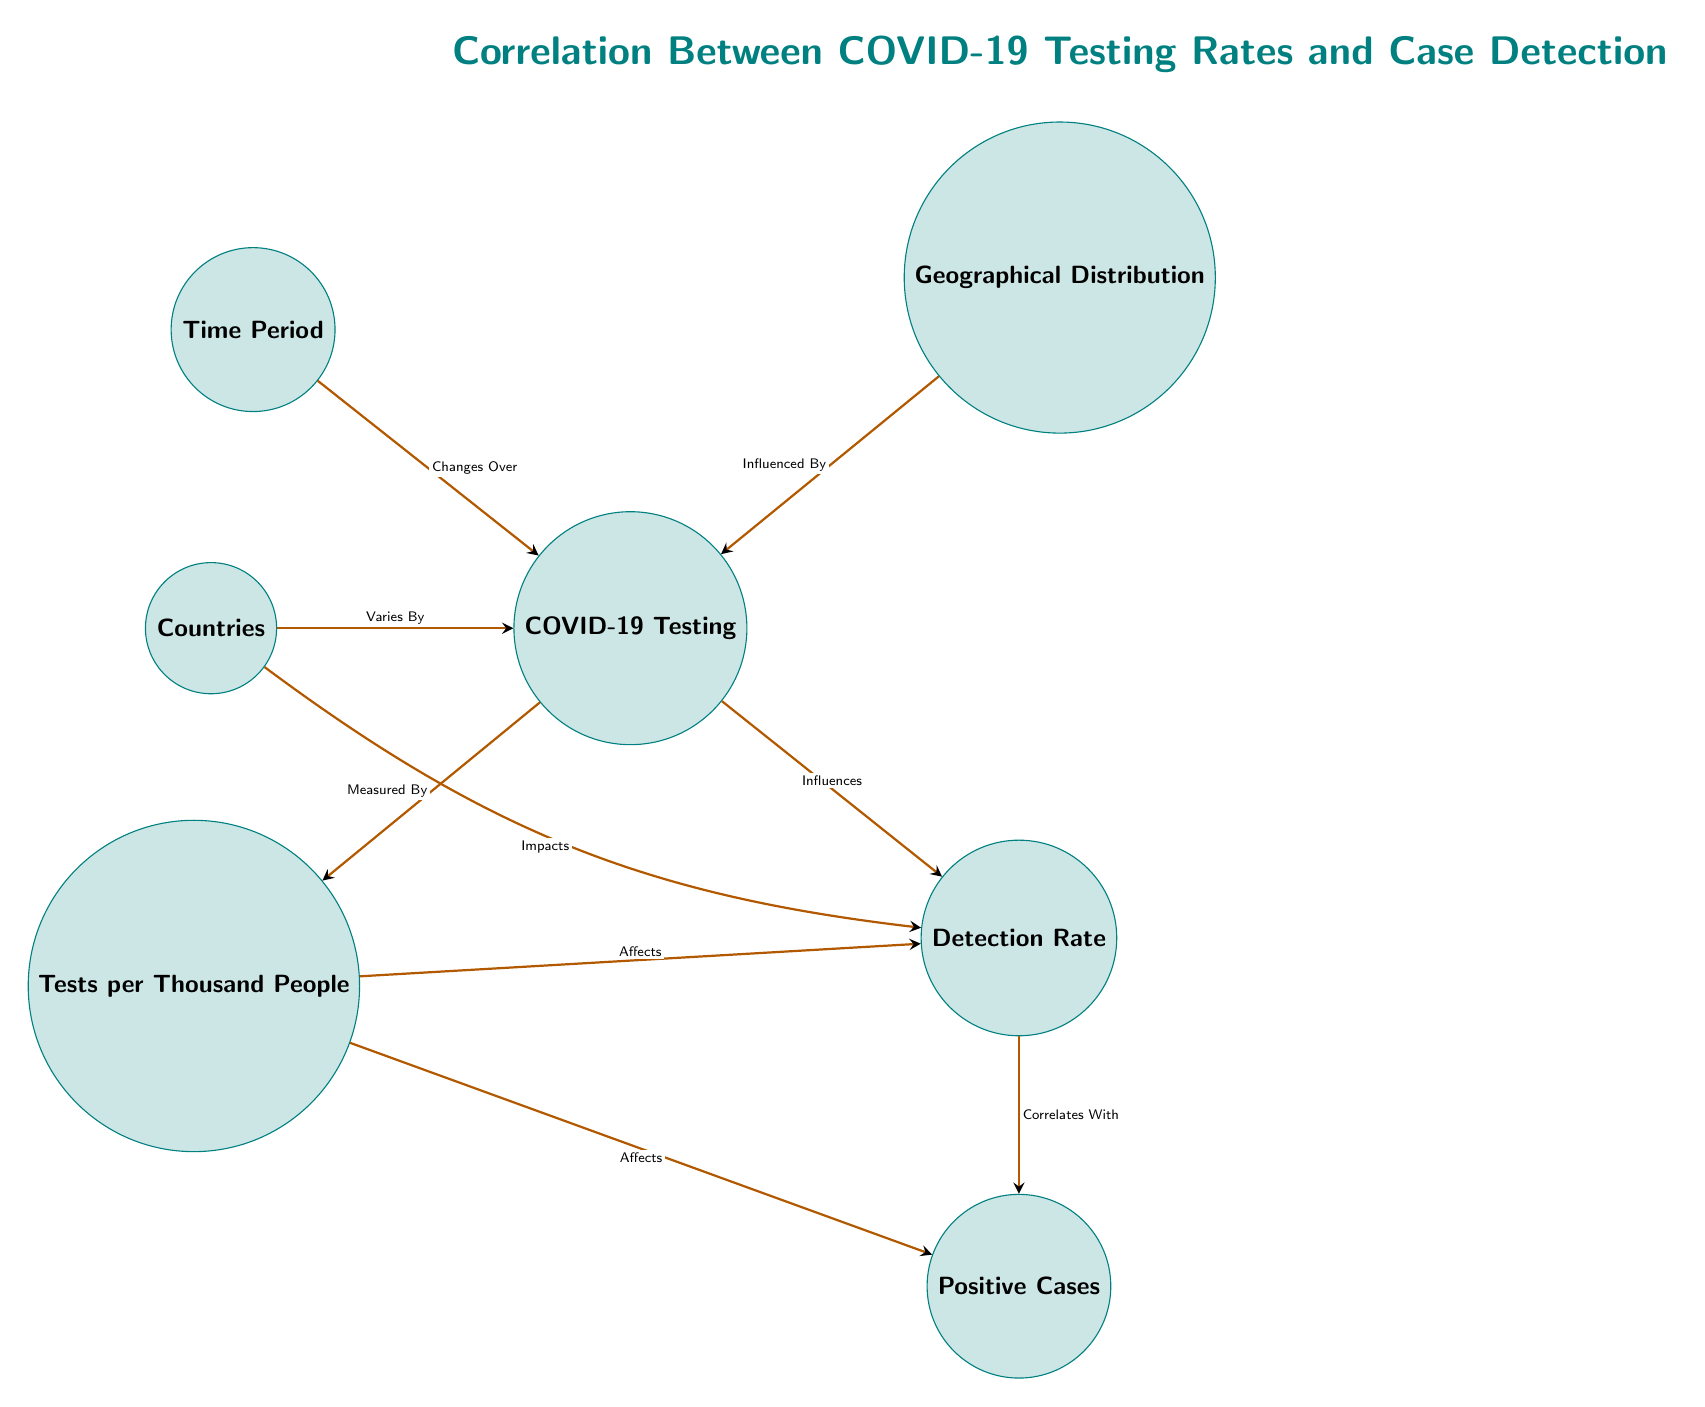What is the top node in the diagram? The top node in the diagram is labeled "Correlation Between COVID-19 Testing Rates and Case Detection," which indicates the primary focus of the diagram.
Answer: Correlation Between COVID-19 Testing Rates and Case Detection How many main nodes are in the diagram? The diagram contains seven main nodes, including the primary node and the nodes depicting various factors related to COVID-19 testing and detection.
Answer: Seven What does "COVID-19 Testing" influence? The edge show that "COVID-19 Testing" influences "Detection Rate," illustrating that an increase in testing is expected to impact case detection.
Answer: Detection Rate What is measured by "Tests per Thousand People"? According to the edges in the diagram, "Tests per Thousand People" is a metric that specifically indicates the measurement of "COVID-19 Testing."
Answer: COVID-19 Testing Which factor directly correlates with "Positive Cases"? The diagram illustrates that "Detection Rate" directly correlates with "Positive Cases," establishing a link between the rate of detection and the number of cases.
Answer: Detection Rate How does "Tests per Thousand People" affect "Detection Rate"? The diagram indicates a direct edge labeled "Affects" between "Tests per Thousand People" and "Detection Rate," meaning that higher testing rates can lead to changes in the detection rate of cases.
Answer: Affects Which two factors vary by "Countries"? The edges in the diagram indicate that "Countries" vary by both "COVID-19 Testing" and "Detection Rate," showing that testing practices and detection can differ based on the country.
Answer: COVID-19 Testing, Detection Rate What influences "COVID-19 Testing"? The diagram shows that several factors influence "COVID-19 Testing," including "Time Period" and "Geographical Distribution," indicating that testing approaches can change over time and across regions.
Answer: Time Period, Geographical Distribution 